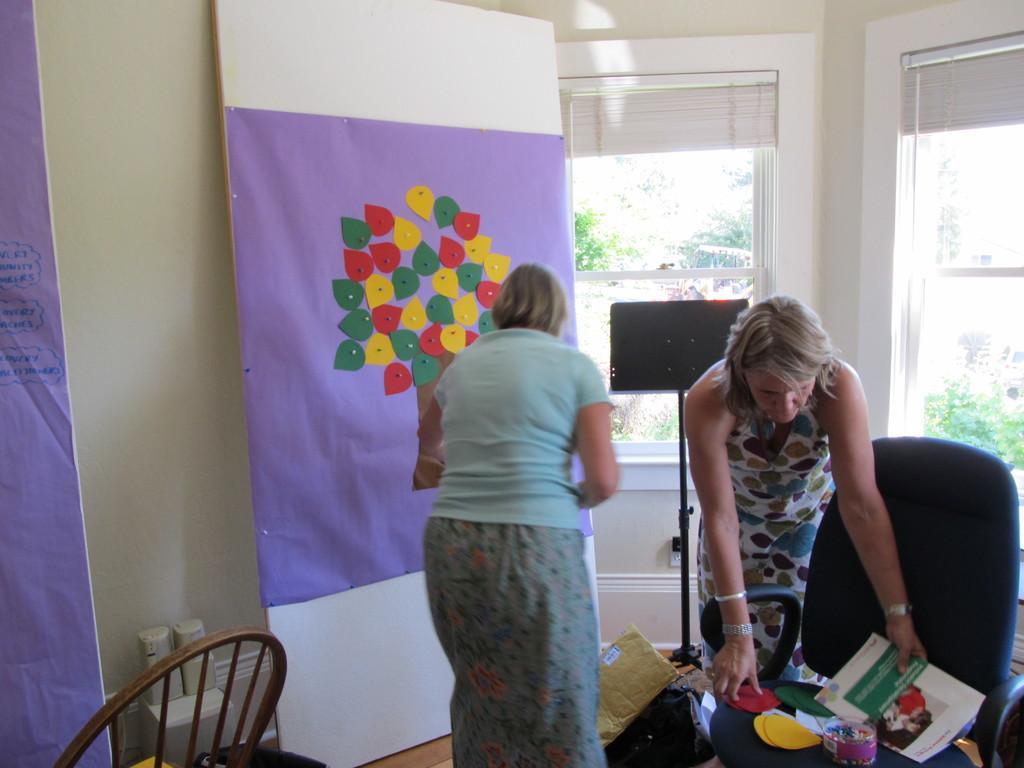Can you describe this image briefly? In this image there is a person. In front of her there is a chair. On top of the chair there are a few objects. Beside the chair there is another person. In front of her there are a few objects. On the left side of the image there is a chair. In front of the chair there are some objects. On the right side of the image there are glass windows through which we can see trees. In front of the glass window there is a board. On the left side of the image there are banners. In the background of the image there is a wall. 